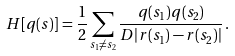<formula> <loc_0><loc_0><loc_500><loc_500>H [ q ( s ) ] = \frac { 1 } { 2 } \sum _ { s _ { 1 } \not = s _ { 2 } } \frac { q ( s _ { 1 } ) q ( s _ { 2 } ) } { D | r ( s _ { 1 } ) - r ( s _ { 2 } ) | } \, .</formula> 